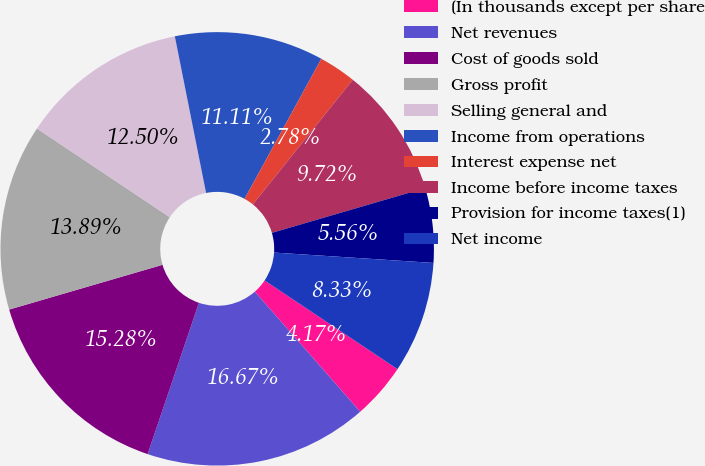Convert chart to OTSL. <chart><loc_0><loc_0><loc_500><loc_500><pie_chart><fcel>(In thousands except per share<fcel>Net revenues<fcel>Cost of goods sold<fcel>Gross profit<fcel>Selling general and<fcel>Income from operations<fcel>Interest expense net<fcel>Income before income taxes<fcel>Provision for income taxes(1)<fcel>Net income<nl><fcel>4.17%<fcel>16.67%<fcel>15.28%<fcel>13.89%<fcel>12.5%<fcel>11.11%<fcel>2.78%<fcel>9.72%<fcel>5.56%<fcel>8.33%<nl></chart> 